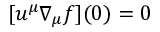<formula> <loc_0><loc_0><loc_500><loc_500>[ u ^ { \mu } \nabla _ { \mu } f ] ( 0 ) = 0</formula> 